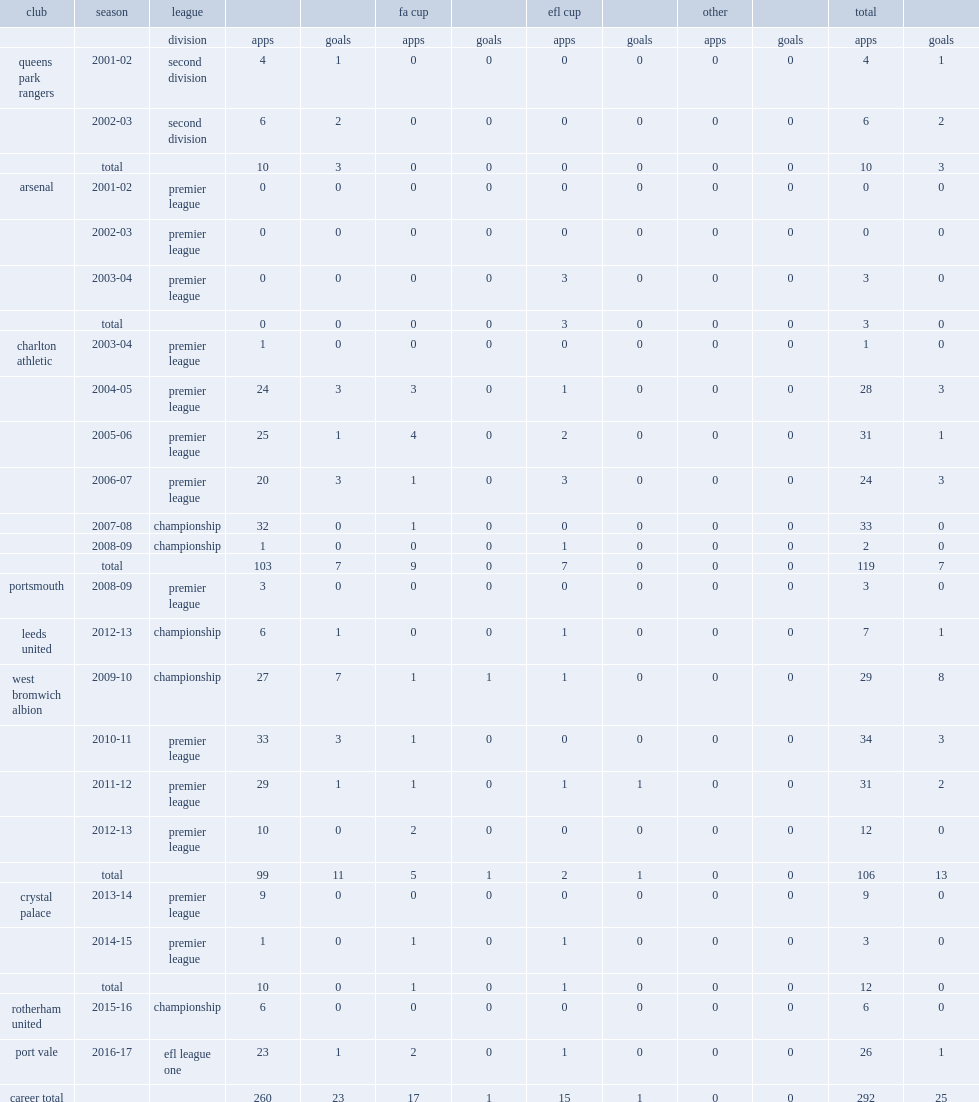Which league did jerome thomas sign with west bromwich albion in 2009 at the 2009-10 season? Championship. 